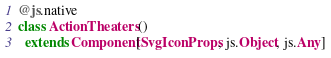<code> <loc_0><loc_0><loc_500><loc_500><_Scala_>@js.native
class ActionTheaters ()
  extends Component[SvgIconProps, js.Object, js.Any]
</code> 